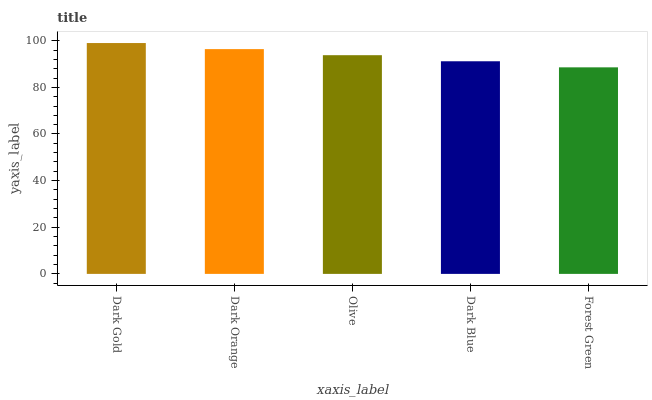Is Forest Green the minimum?
Answer yes or no. Yes. Is Dark Gold the maximum?
Answer yes or no. Yes. Is Dark Orange the minimum?
Answer yes or no. No. Is Dark Orange the maximum?
Answer yes or no. No. Is Dark Gold greater than Dark Orange?
Answer yes or no. Yes. Is Dark Orange less than Dark Gold?
Answer yes or no. Yes. Is Dark Orange greater than Dark Gold?
Answer yes or no. No. Is Dark Gold less than Dark Orange?
Answer yes or no. No. Is Olive the high median?
Answer yes or no. Yes. Is Olive the low median?
Answer yes or no. Yes. Is Forest Green the high median?
Answer yes or no. No. Is Dark Gold the low median?
Answer yes or no. No. 